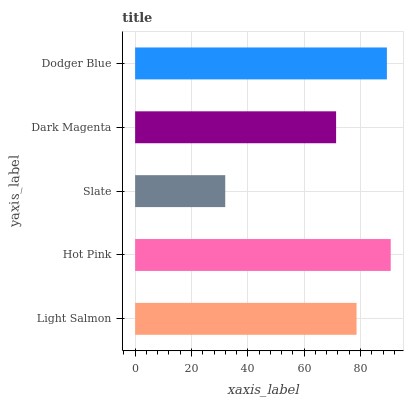Is Slate the minimum?
Answer yes or no. Yes. Is Hot Pink the maximum?
Answer yes or no. Yes. Is Hot Pink the minimum?
Answer yes or no. No. Is Slate the maximum?
Answer yes or no. No. Is Hot Pink greater than Slate?
Answer yes or no. Yes. Is Slate less than Hot Pink?
Answer yes or no. Yes. Is Slate greater than Hot Pink?
Answer yes or no. No. Is Hot Pink less than Slate?
Answer yes or no. No. Is Light Salmon the high median?
Answer yes or no. Yes. Is Light Salmon the low median?
Answer yes or no. Yes. Is Dodger Blue the high median?
Answer yes or no. No. Is Hot Pink the low median?
Answer yes or no. No. 